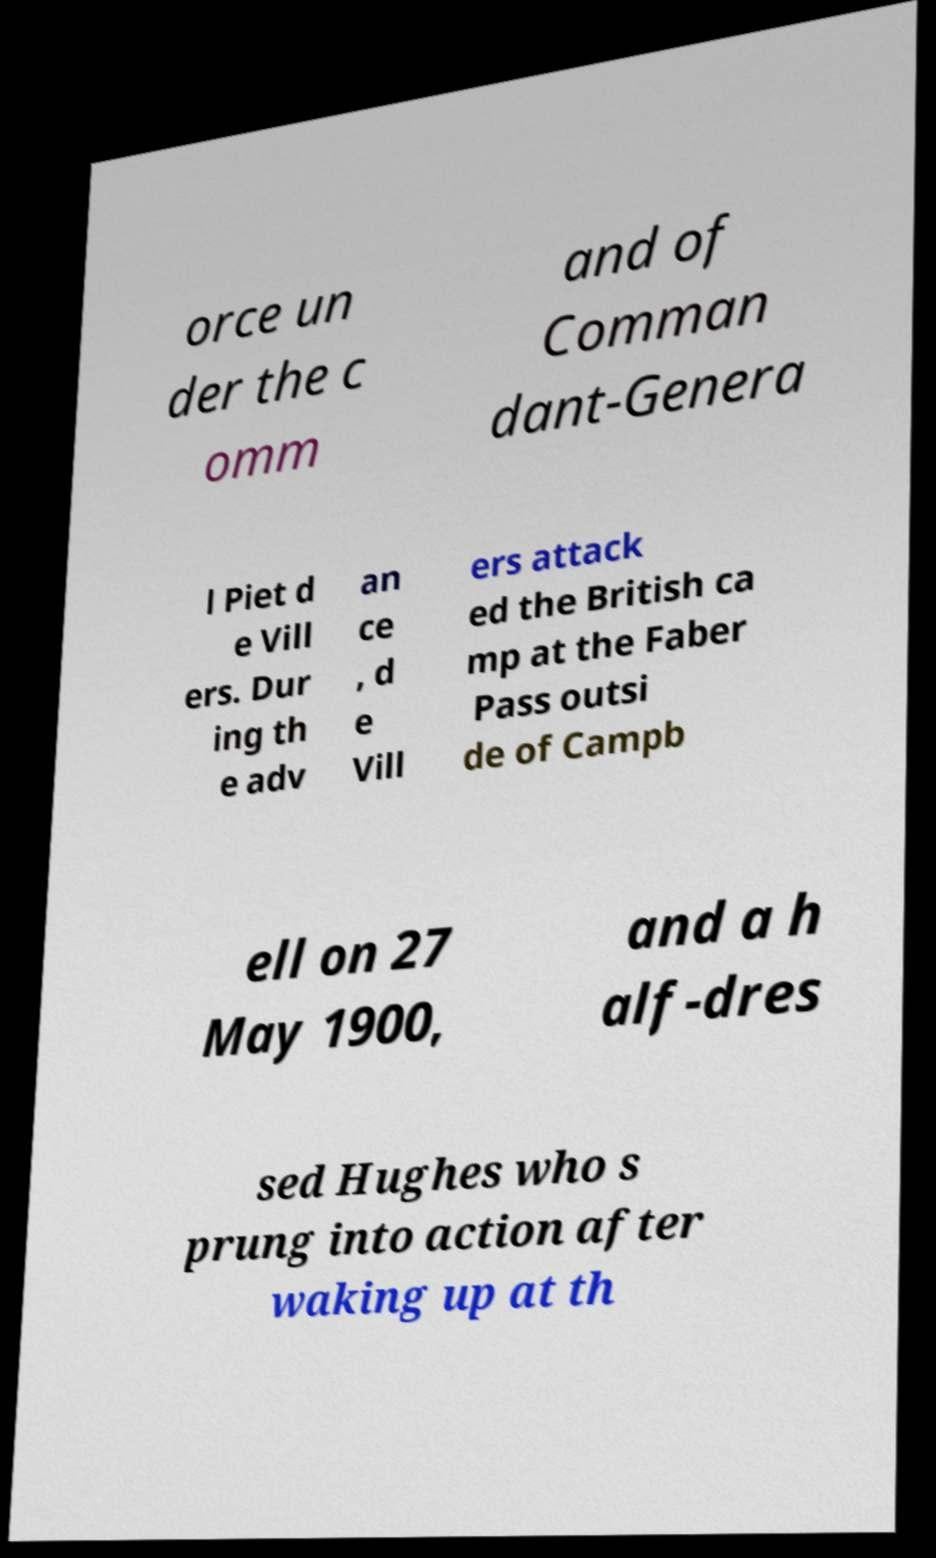There's text embedded in this image that I need extracted. Can you transcribe it verbatim? orce un der the c omm and of Comman dant-Genera l Piet d e Vill ers. Dur ing th e adv an ce , d e Vill ers attack ed the British ca mp at the Faber Pass outsi de of Campb ell on 27 May 1900, and a h alf-dres sed Hughes who s prung into action after waking up at th 